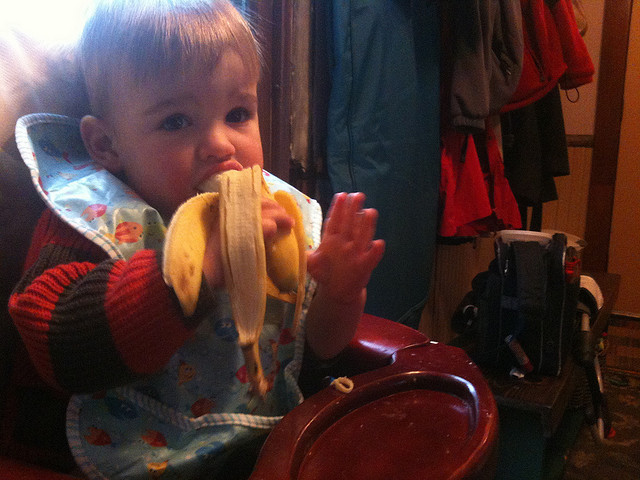<image>What food does the child have on his plate? I don't know what food the child has on his plate. It can be a banana or nothing. What food does the child have on his plate? I don't know what food the child has on his plate. It can be seen both banana and nothing. 